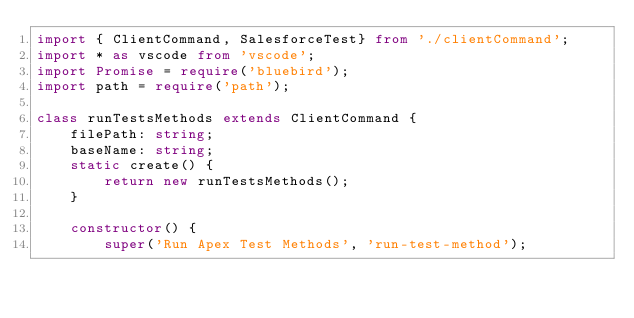Convert code to text. <code><loc_0><loc_0><loc_500><loc_500><_TypeScript_>import { ClientCommand, SalesforceTest} from './clientCommand';
import * as vscode from 'vscode';
import Promise = require('bluebird');
import path = require('path');

class runTestsMethods extends ClientCommand {
    filePath: string;
    baseName: string;
    static create() {
        return new runTestsMethods();
    }

    constructor() {
        super('Run Apex Test Methods', 'run-test-method');</code> 